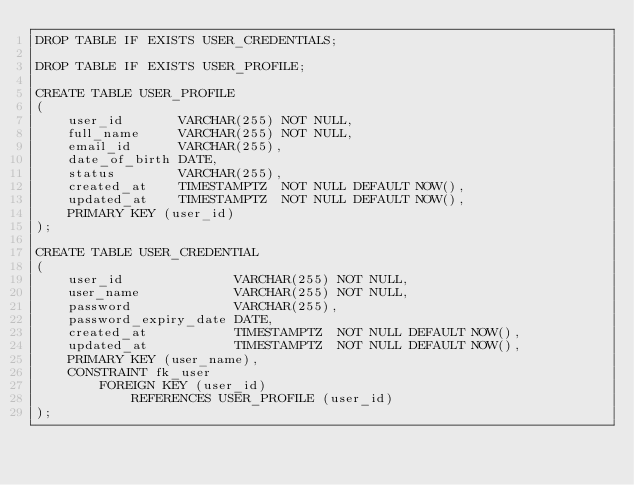<code> <loc_0><loc_0><loc_500><loc_500><_SQL_>DROP TABLE IF EXISTS USER_CREDENTIALS;

DROP TABLE IF EXISTS USER_PROFILE;

CREATE TABLE USER_PROFILE
(
    user_id       VARCHAR(255) NOT NULL,
    full_name     VARCHAR(255) NOT NULL,
    email_id      VARCHAR(255),
    date_of_birth DATE,
    status        VARCHAR(255),
    created_at    TIMESTAMPTZ  NOT NULL DEFAULT NOW(),
    updated_at    TIMESTAMPTZ  NOT NULL DEFAULT NOW(),
    PRIMARY KEY (user_id)
);

CREATE TABLE USER_CREDENTIAL
(
    user_id              VARCHAR(255) NOT NULL,
    user_name            VARCHAR(255) NOT NULL,
    password             VARCHAR(255),
    password_expiry_date DATE,
    created_at           TIMESTAMPTZ  NOT NULL DEFAULT NOW(),
    updated_at           TIMESTAMPTZ  NOT NULL DEFAULT NOW(),
    PRIMARY KEY (user_name),
    CONSTRAINT fk_user
        FOREIGN KEY (user_id)
            REFERENCES USER_PROFILE (user_id)
);</code> 